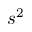<formula> <loc_0><loc_0><loc_500><loc_500>s ^ { 2 }</formula> 